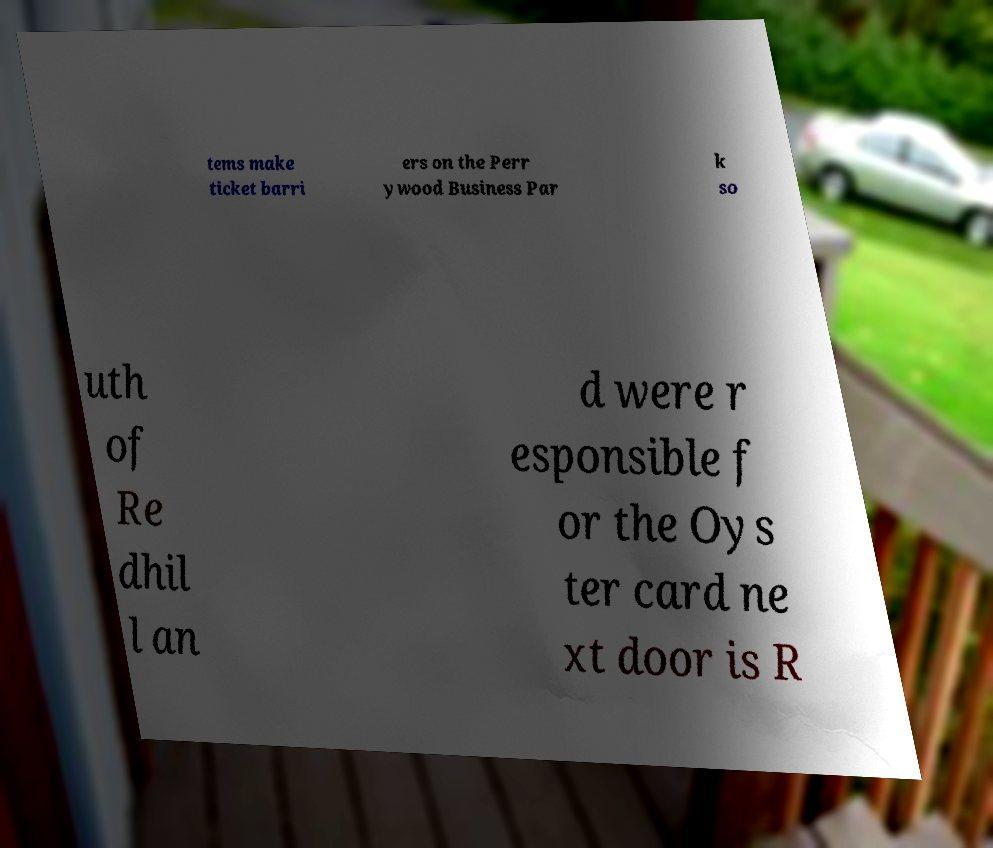For documentation purposes, I need the text within this image transcribed. Could you provide that? tems make ticket barri ers on the Perr ywood Business Par k so uth of Re dhil l an d were r esponsible f or the Oys ter card ne xt door is R 